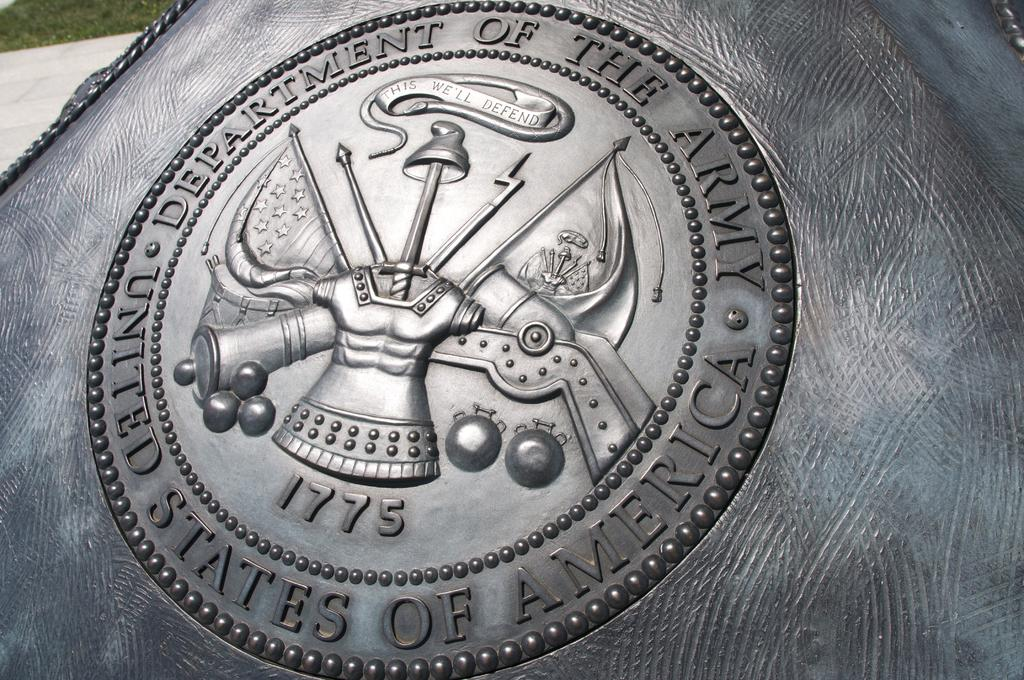<image>
Share a concise interpretation of the image provided. The seal of the Department of the Army is shown on a monument. 